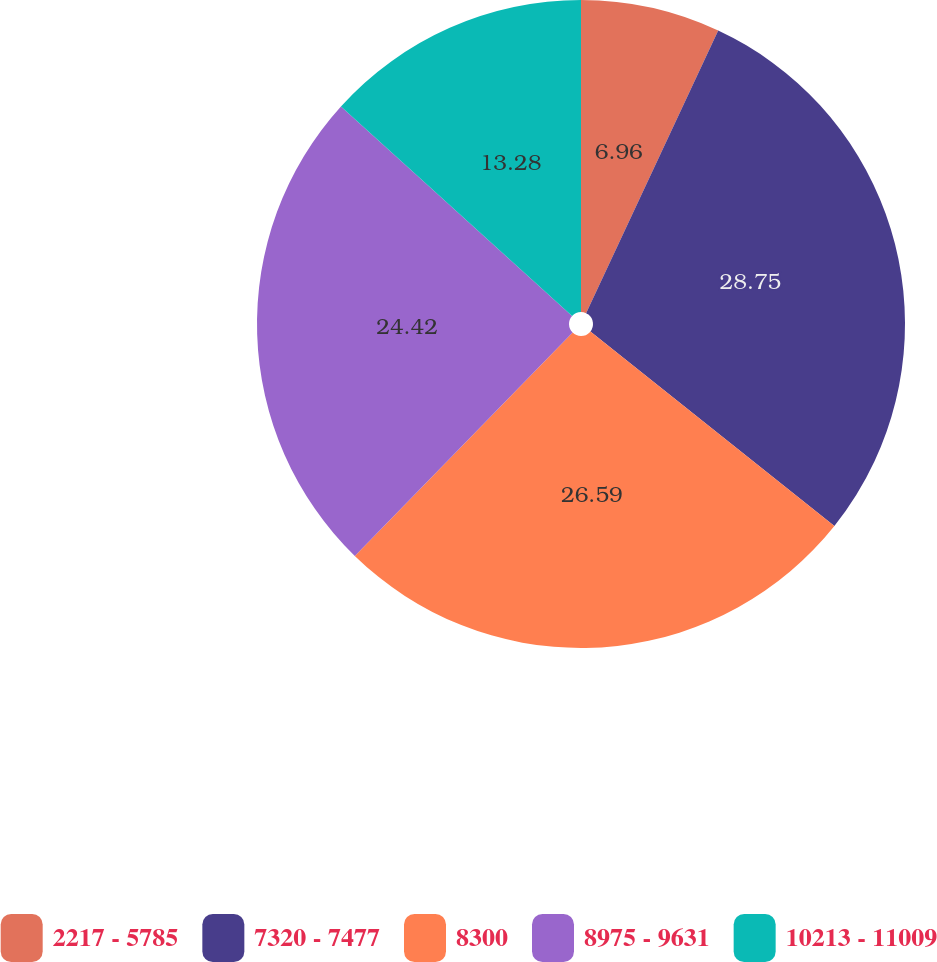Convert chart to OTSL. <chart><loc_0><loc_0><loc_500><loc_500><pie_chart><fcel>2217 - 5785<fcel>7320 - 7477<fcel>8300<fcel>8975 - 9631<fcel>10213 - 11009<nl><fcel>6.96%<fcel>28.75%<fcel>26.59%<fcel>24.42%<fcel>13.28%<nl></chart> 